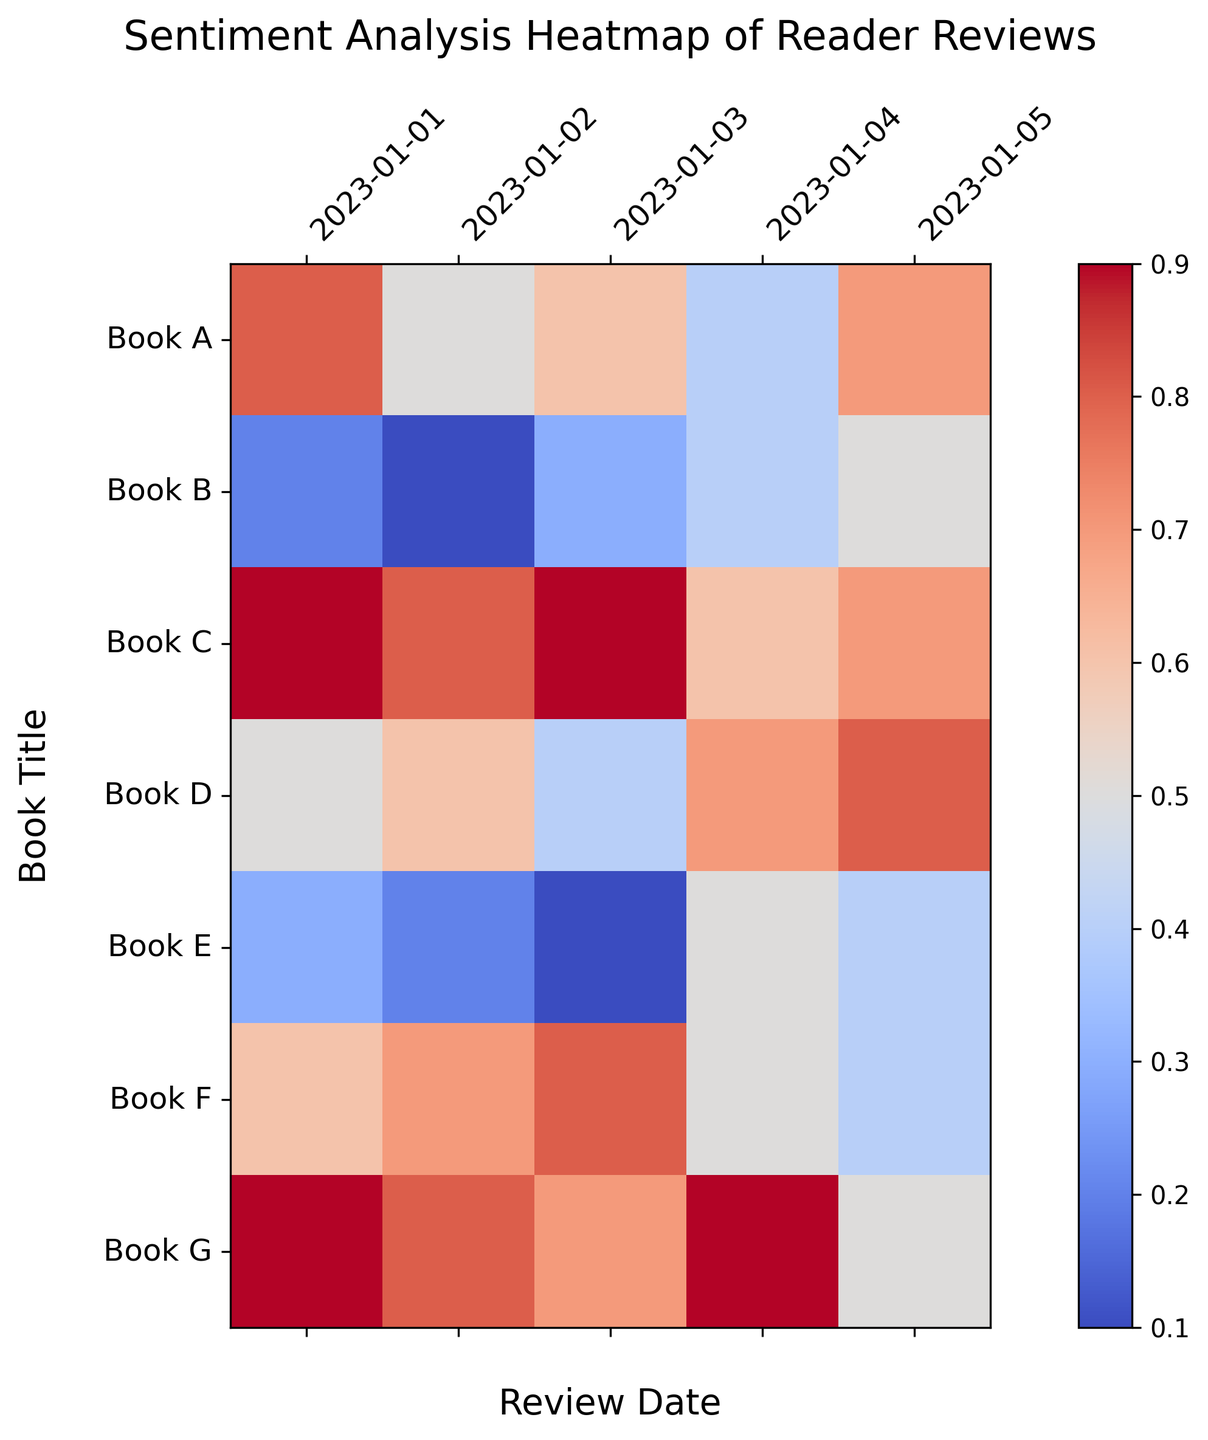Which book shows the highest sentiment score on January 3rd? Look at the column for January 3rd and identify the cell with the highest value. The highest sentiment score is 0.9 for Book C.
Answer: Book C What is the average sentiment score for Book A over the given dates? Add the sentiment scores for Book A (0.8 + 0.5 + 0.6 + 0.4 + 0.7) and divide by the number of dates (5). The average is (0.8 + 0.5 + 0.6 + 0.4 + 0.7) / 5 = 3.0 / 5 = 0.6.
Answer: 0.6 Which book has the most inconsistent sentiment scores? Compare the color variations for each book across the dates. The book with the widest range of colors indicates the highest inconsistency. Book B ranges from 0.1 to 0.5, which indicates the most inconsistency.
Answer: Book B How does the sentiment score for Book E on January 1st compare to Book F on the same date? Look at the cells for both books on January 1st. Book E has a sentiment score of 0.3, whereas Book F has a sentiment score of 0.6. Hence, Book F's sentiment score is higher.
Answer: Book F is higher Which book appears to show improving sentiment scores over the dates? Check for a trend where the scores increase over time. Book D shows an improving trend from 0.5 to 0.8 over the dates.
Answer: Book D What is the difference between the highest and lowest sentiment scores for Book C? Identify the highest (0.9) and lowest (0.6) sentiment scores for Book C and then calculate the difference (0.9 - 0.6).
Answer: 0.3 Which book has the lowest sentiment score on January 5th? Look at the column for January 5th and identify the cell with the lowest value. The lowest sentiment score is 0.4 for Book F and Book E.
Answer: Book E, Book F Which two books have the closest sentiment scores on January 2nd? Look at the column for January 2nd and compare values to find the closest ones: Book A (0.5) and Book D (0.6) are closest, with a difference of 0.1.
Answer: Book A, Book D Which book had a sentiment score of 0.7 on January 4th? Look at the column for January 4th and find the cell with a value of 0.7. Book A and Book D both have a sentiment score of 0.7 on that date.
Answer: Book A, Book D Which book shows the greatest improvement in sentiment score from January 1st to January 5th? Calculate the difference for each book from January 1st to January 5th, then identify the greatest increase: Book D improved from 0.5 to 0.8, an increase of 0.3.
Answer: Book D 